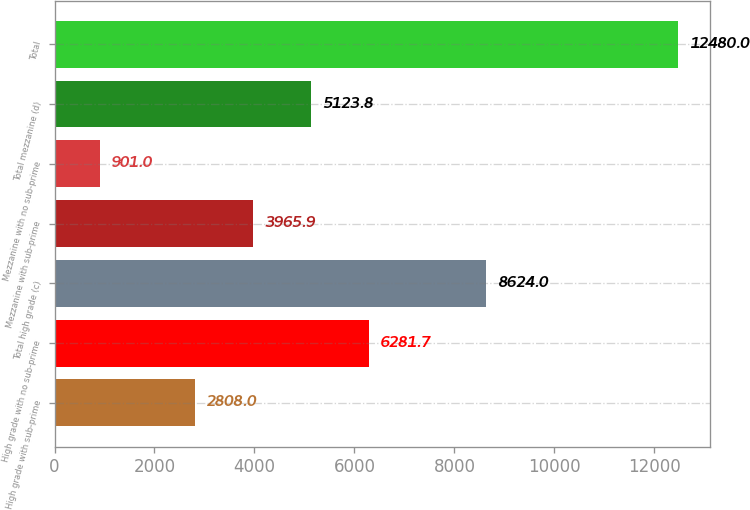<chart> <loc_0><loc_0><loc_500><loc_500><bar_chart><fcel>High grade with sub-prime<fcel>High grade with no sub-prime<fcel>Total high grade (c)<fcel>Mezzanine with sub-prime<fcel>Mezzanine with no sub-prime<fcel>Total mezzanine (d)<fcel>Total<nl><fcel>2808<fcel>6281.7<fcel>8624<fcel>3965.9<fcel>901<fcel>5123.8<fcel>12480<nl></chart> 